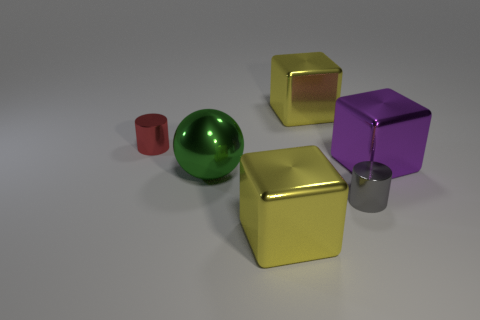What is the shape of the gray object that is made of the same material as the red cylinder? The gray object sharing the same material as the red object is also a cylinder, a geometric shape with straight parallel sides and a circular cross-section. 